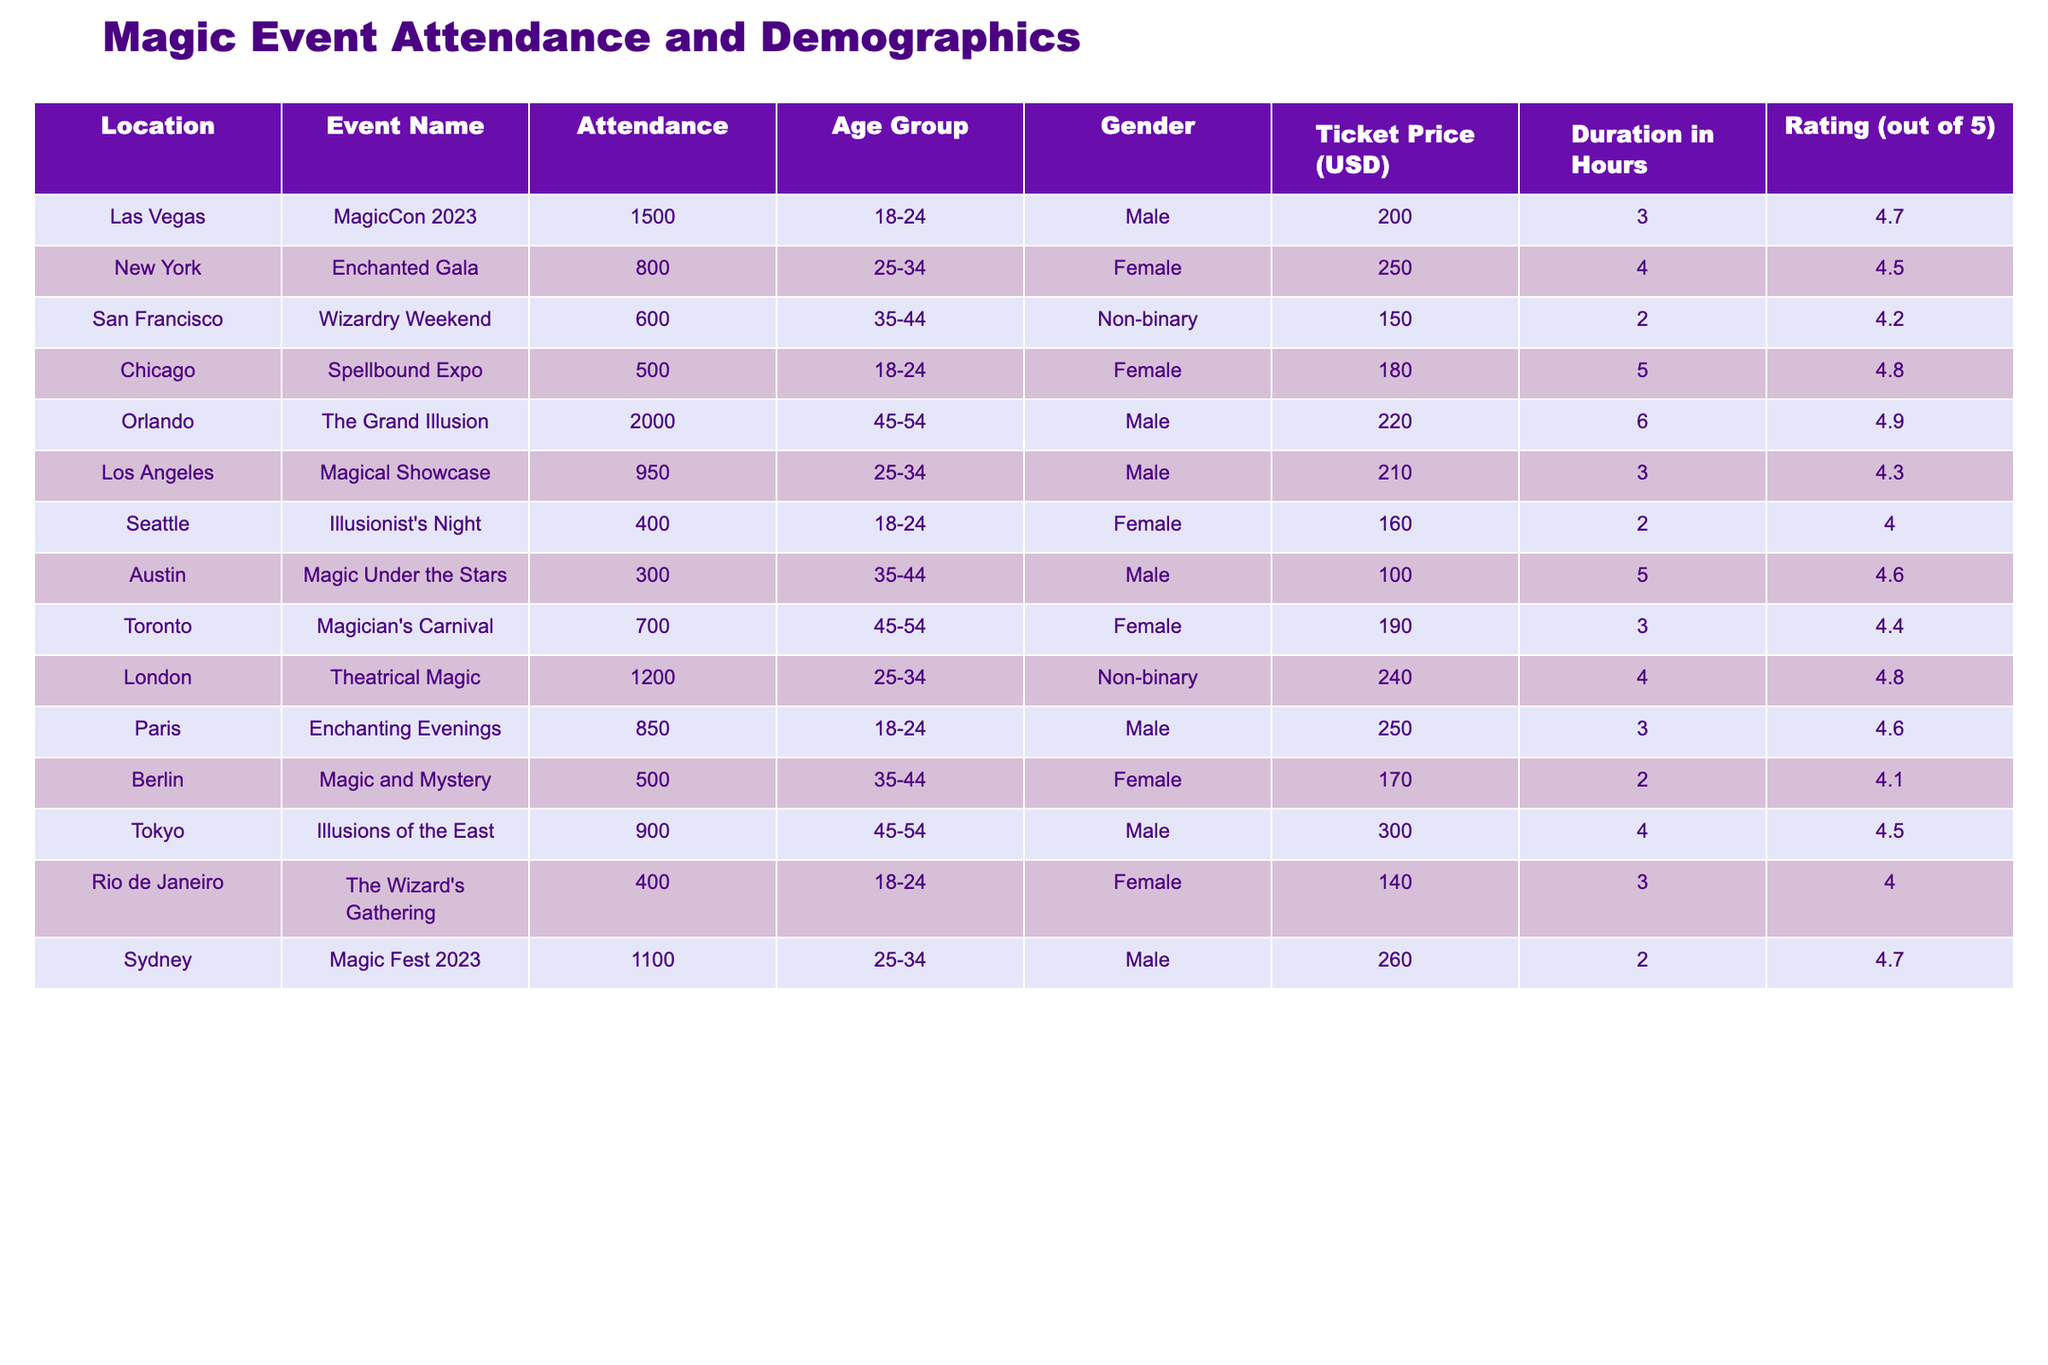What is the highest attendance at any magic event? The highest attendance is found in Orlando at The Grand Illusion with 2000 attendees.
Answer: 2000 How many events had a rating of 4.5 or higher? There are 6 events that have a rating of 4.5 or higher, specifically: MagicCon 2023 (4.7), The Grand Illusion (4.9), Spellbound Expo (4.8), London Theatrical Magic (4.8), Sydney Magic Fest 2023 (4.7), and Enchanting Evenings (4.6).
Answer: 6 What was the average ticket price for all events? The ticket prices are 200, 250, 150, 180, 220, 210, 160, 100, 190, 240, 250, 300, 140, and 260. Summing these gives 2,430. Dividing by the number of events (14), the average ticket price is 2,430/14 = 173.57.
Answer: 173.57 Is there any event with female attendance in the age group 35-44? Yes, there are two events with female attendees in the age group 35-44: Wizardry Weekend and Magic and Mystery.
Answer: Yes Which age group had the highest total attendance? The age group 25-34 had the highest total attendance with 800 (New York) + 950 (Los Angeles) + 1200 (London) + 1100 (Sydney) = 4050.
Answer: 25-34 What is the difference in average duration between events where males participated and events where females participated? Average duration of male events: (3 + 6 + 3 + 4 + 2 + 5) = 23; total events: 6 → average = 23/6 = 3.83. Average duration of female events: (4 + 5 + 2 + 3 + 2) = 16; total events: 5 → average = 16/5 = 3.2. The difference is 3.83 - 3.2 = 0.63 hours.
Answer: 0.63 hours What percentage of attendees were in the 45-54 age group? The total attendance is 1500 + 800 + 600 + 500 + 2000 + 950 + 400 + 300 + 700 + 1200 + 850 + 500 + 900 + 400 + 1100 = 10300. The total attendance in the 45-54 age group is 2000 (Orlando) + 700 (Toronto) + 900 (Tokyo) = 3600. The percentage is (3600/10300) * 100 = 34.95%.
Answer: 34.95% Which event had the lowest attendance and what was its rating? The event with the lowest attendance is the The Wizard's Gathering in Rio de Janeiro, with 400 attendees and a rating of 4.0.
Answer: 4.0 Is there a non-binary participant attending any magic event in San Francisco? Yes, at Wizardry Weekend in San Francisco, there was a non-binary attendee.
Answer: Yes 